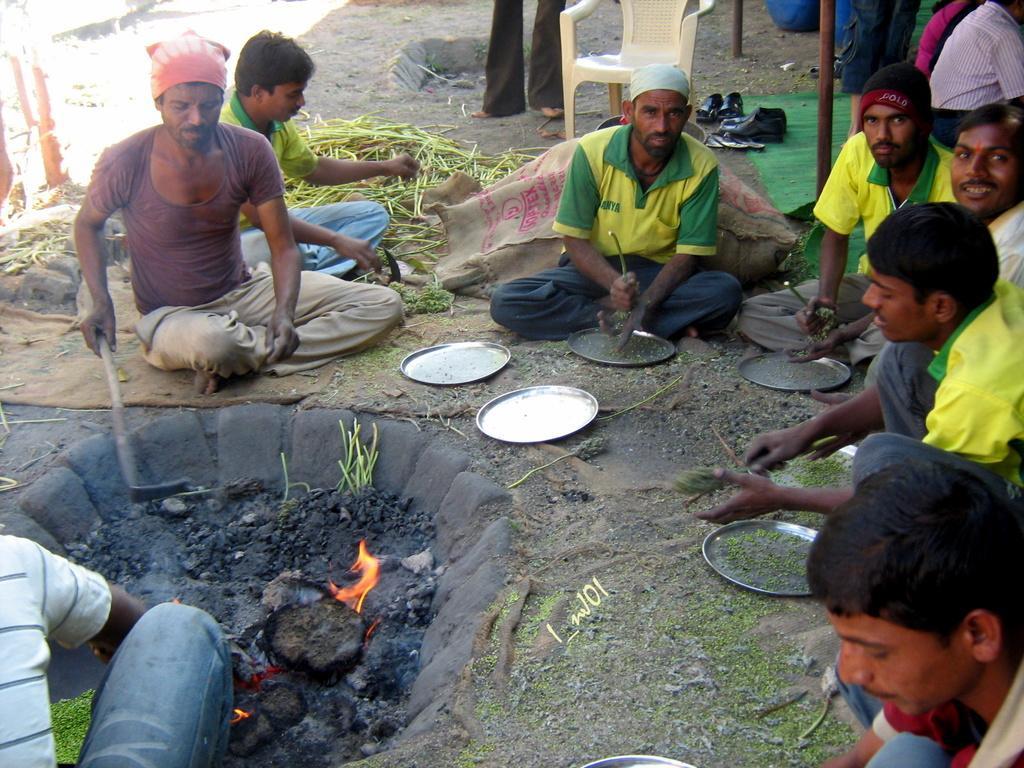Could you give a brief overview of what you see in this image? In this image I can see number of persons are sitting on the ground and I can see few of them are holding few objects in their hands. I can see some coal and fire on the ground. In the background I can see a chair, few metal poles, the carpet and few pairs of footwear on the ground. 